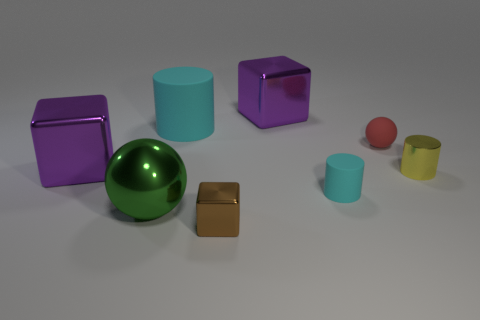What is the material of the small cylinder that is the same color as the large cylinder? rubber 